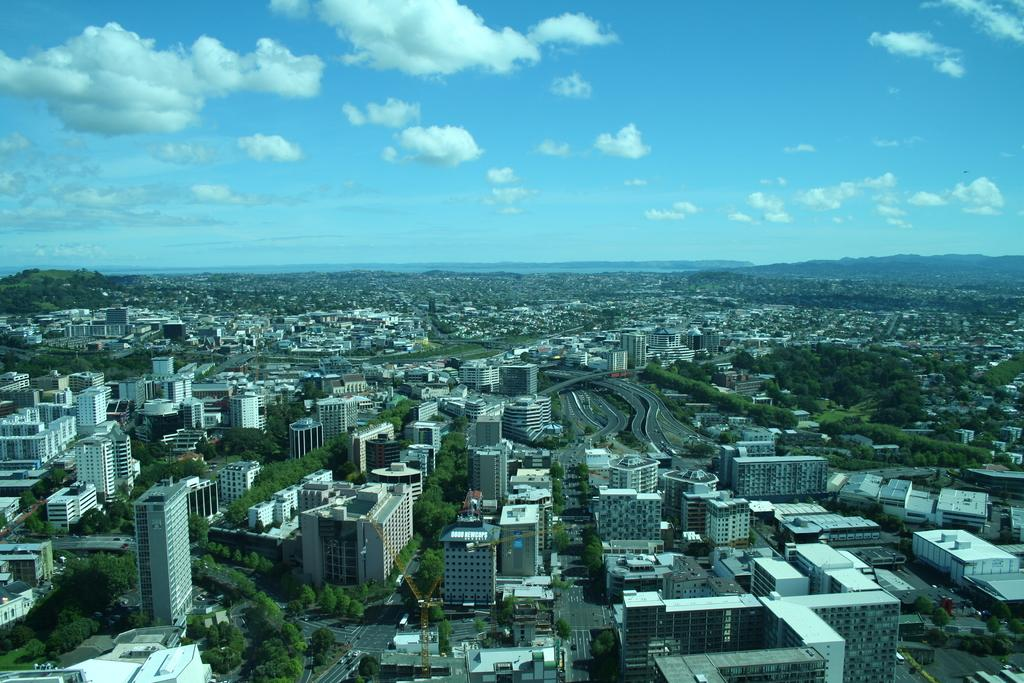What types of structures are present in the image? There are buildings and houses in the image. What else can be seen in the image besides structures? There are trees and vehicles on the road in the image. What is visible behind the buildings? There are hills visible behind the buildings. What part of the natural environment is visible in the image? The sky is visible in the image. Can you see a swing on one of the trees in the image? There is no swing visible on any of the trees in the image. 